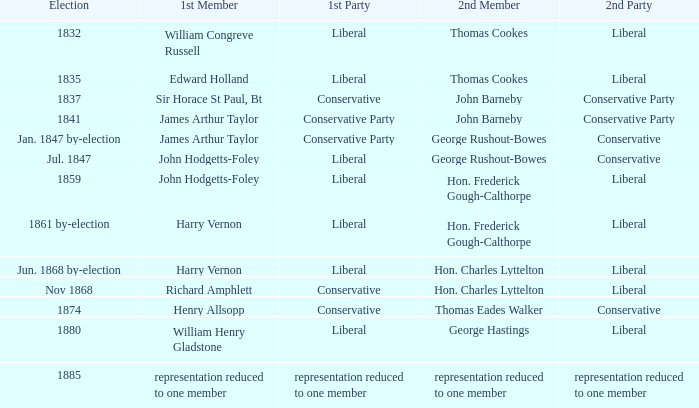What was the 2nd Party that had the 2nd Member John Barneby, when the 1st Party was Conservative? Conservative Party. 